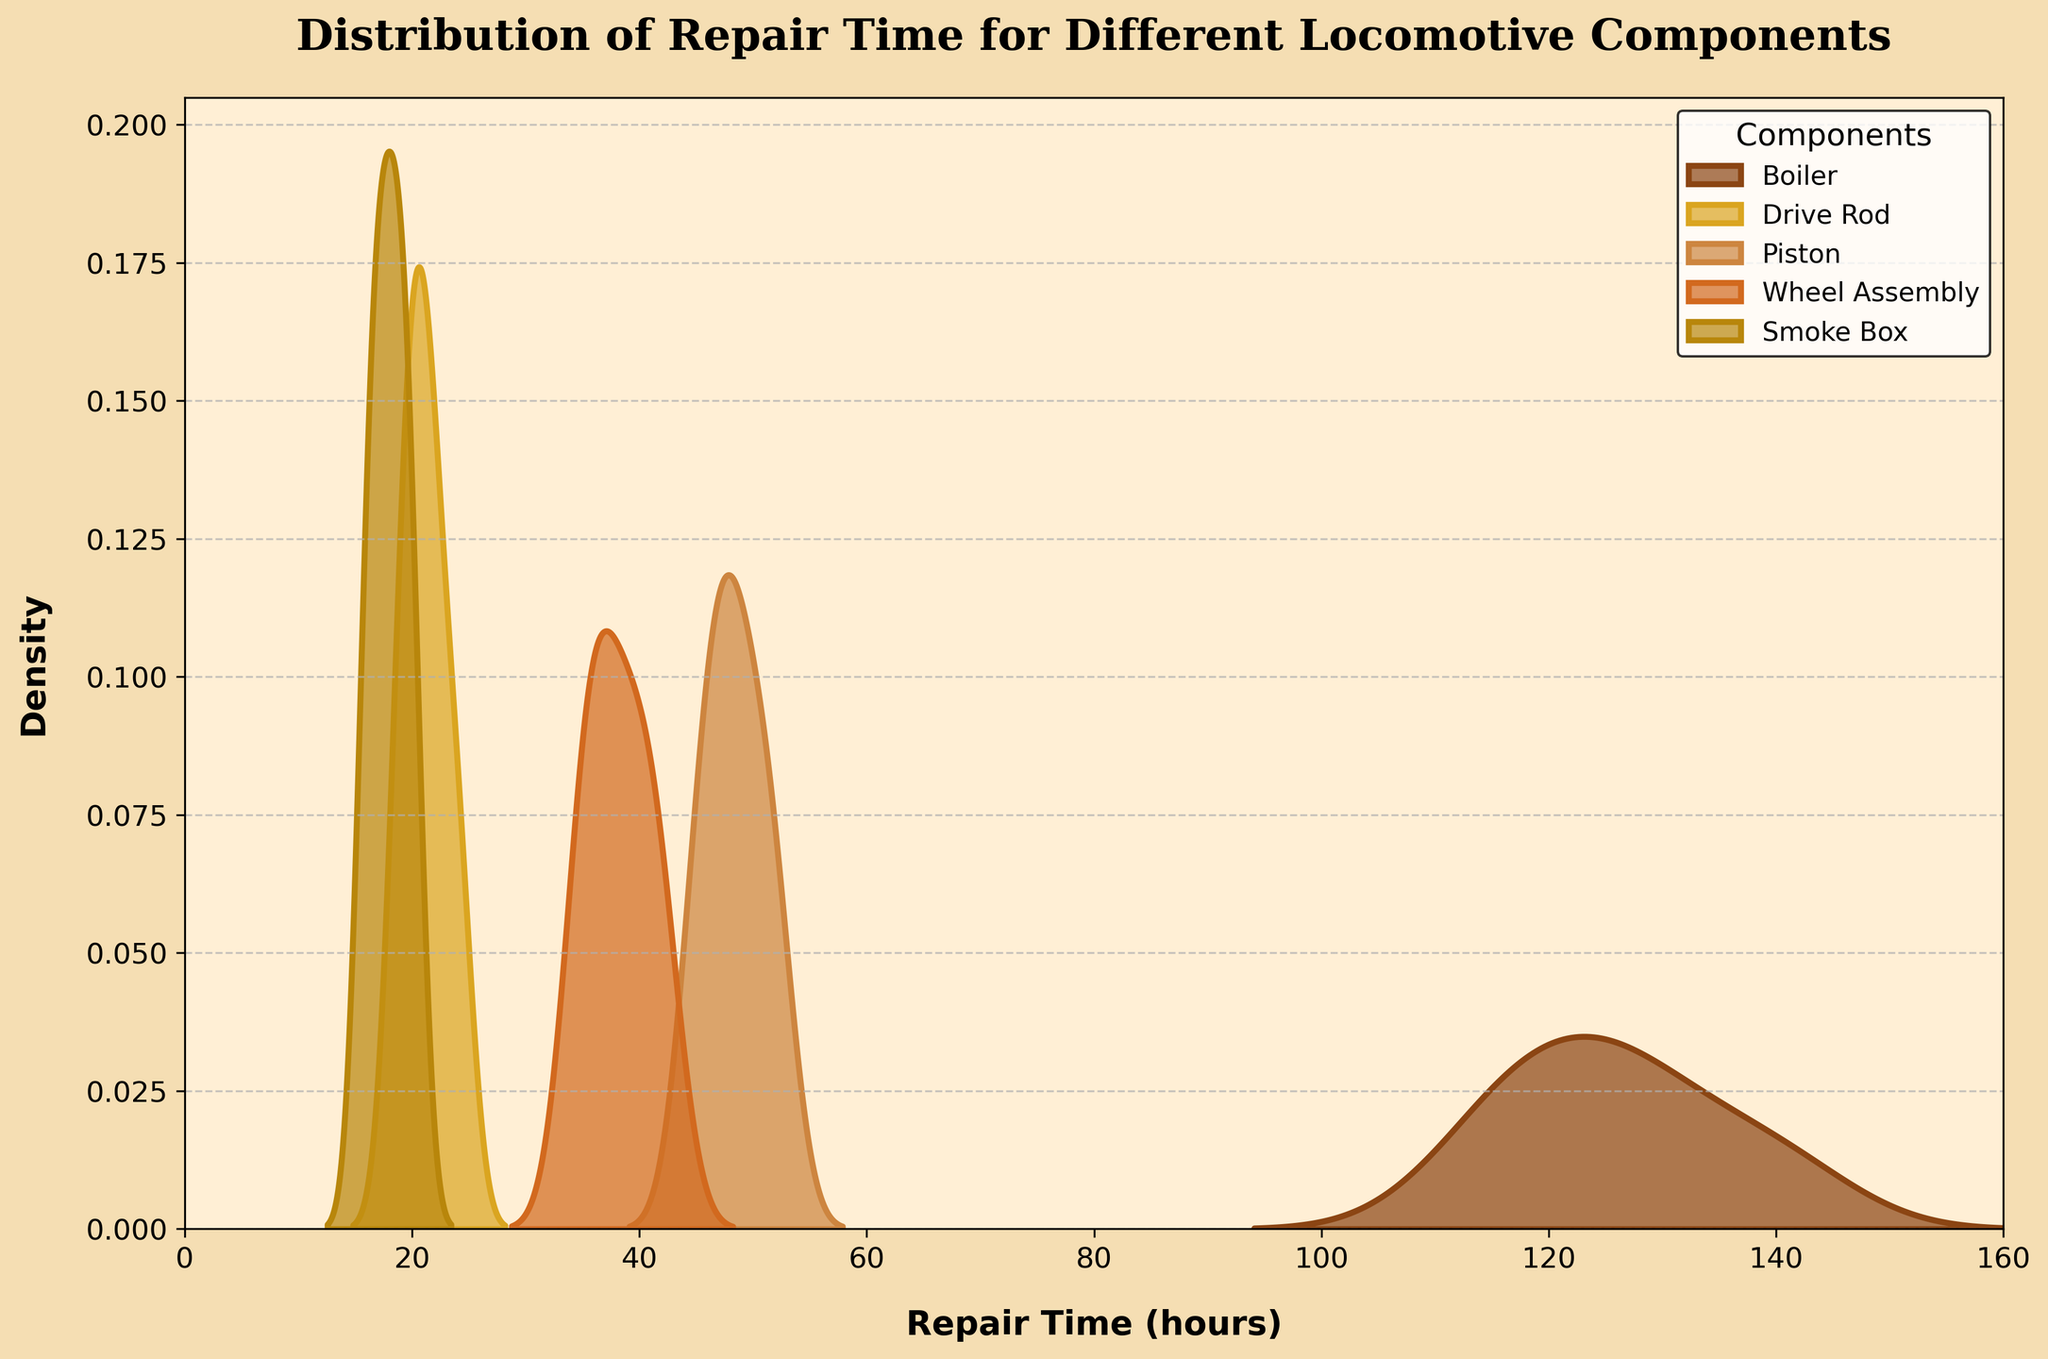What is the component with the longest average repair time? Look at the peaks of the density curves. The Boiler component shows the longest repair times around 120-140 hours.
Answer: Boiler How many components are displayed in the plot? Count the unique color-coded density plots in the legend. There are five components listed.
Answer: Five Which component has the shortest repair time range shown in the plot? Identify the component with the density plot that has the shortest horizontal spread. The Smoke Box component has the shortest repair times, around 16-20 hours.
Answer: Smoke Box What is the range of repair times for the Piston component? Look at the spread of the density plot for the Piston component. It ranges roughly from 45 to 52 hours.
Answer: 45-52 hours Which component shows the highest peak in the density curves? Observe the height of the peaks in the density curves. The Drive Rod component exhibits the highest peak.
Answer: Drive Rod What is the difference between the maximum repair times for the Boiler and Smoke Box components? Compare the maximum repair time for the Boiler (around 140 hours) and the Smoke Box (around 20 hours). The difference is 140 - 20 = 120 hours.
Answer: 120 hours Which component's repair times overlap with those of the Wheel Assembly? Look for other density curves overlapping with the Wheel Assembly's. The Piston's repair times (45-52 hours) overlap slightly with those of the Wheel Assembly (35-42 hours).
Answer: Piston Are there any components with repair times that do not overlap with any other components? Check all the density plots for overlaps. The Boiler component's repair times (115-140 hours) do not overlap with any other component.
Answer: Boiler What is the title of the plot? Check the text at the top of the plot. The title is 'Distribution of Repair Time for Different Locomotive Components'.
Answer: Distribution of Repair Time for Different Locomotive Components What are the units of the x-axis? Look at the label on the x-axis. It states 'Repair Time (hours)'.
Answer: Hours 